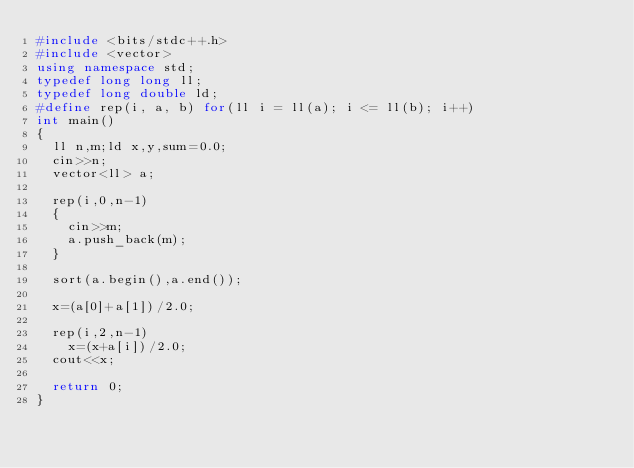Convert code to text. <code><loc_0><loc_0><loc_500><loc_500><_C++_>#include <bits/stdc++.h>
#include <vector>
using namespace std;
typedef long long ll;
typedef long double ld;
#define rep(i, a, b) for(ll i = ll(a); i <= ll(b); i++)
int main()
{
	ll n,m;ld x,y,sum=0.0;
	cin>>n;
	vector<ll> a;

	rep(i,0,n-1)
	{
		cin>>m;
		a.push_back(m);
	}

	sort(a.begin(),a.end());

	x=(a[0]+a[1])/2.0;

	rep(i,2,n-1)
		x=(x+a[i])/2.0;
	cout<<x;

	return 0;
}</code> 